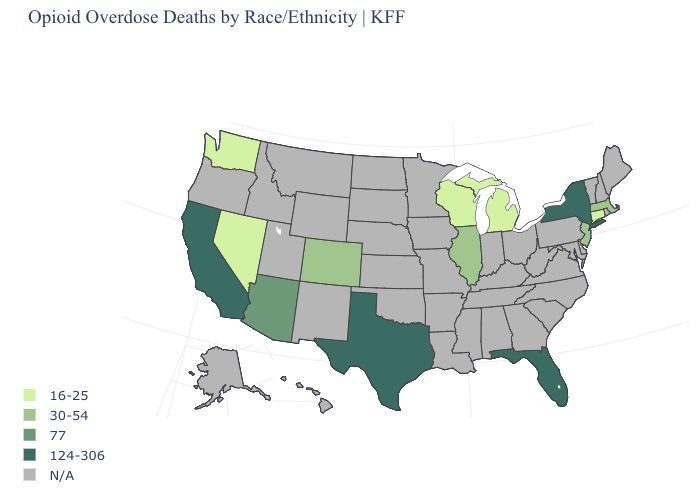What is the value of New Mexico?
Answer briefly. N/A. Which states have the lowest value in the South?
Quick response, please. Florida, Texas. Name the states that have a value in the range 16-25?
Answer briefly. Connecticut, Michigan, Nevada, Washington, Wisconsin. Is the legend a continuous bar?
Short answer required. No. What is the lowest value in the USA?
Concise answer only. 16-25. What is the value of Pennsylvania?
Write a very short answer. N/A. What is the lowest value in states that border Iowa?
Be succinct. 16-25. What is the value of Montana?
Quick response, please. N/A. Does the map have missing data?
Answer briefly. Yes. What is the value of Ohio?
Be succinct. N/A. What is the highest value in states that border Idaho?
Be succinct. 16-25. Name the states that have a value in the range 16-25?
Keep it brief. Connecticut, Michigan, Nevada, Washington, Wisconsin. 